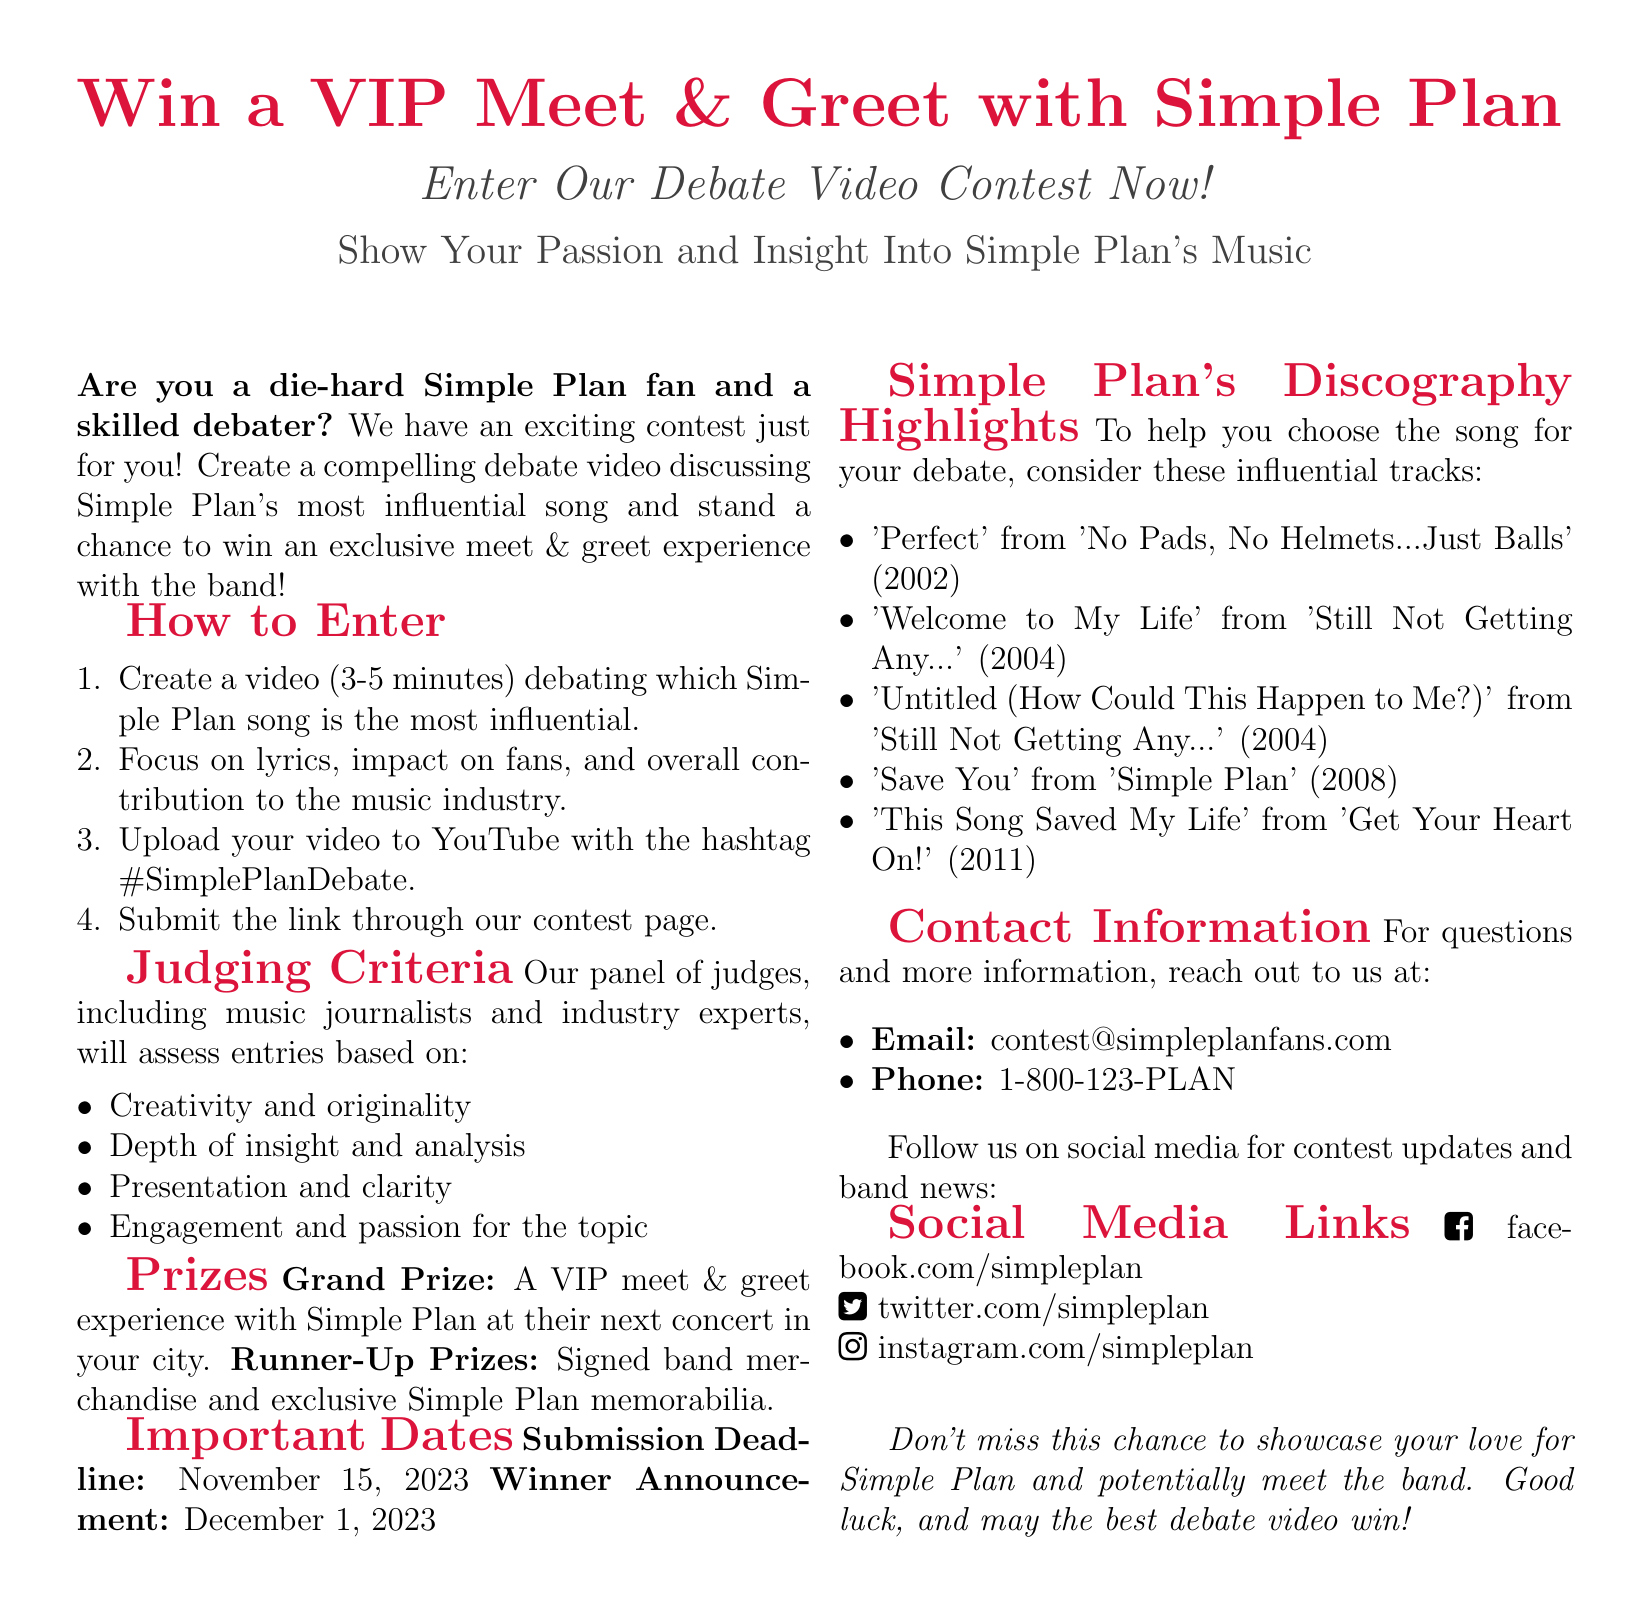What is the contest prize? The grand prize is a VIP meet & greet experience with Simple Plan at their next concert.
Answer: VIP meet & greet experience What is the video length requirement? The video should be between 3 to 5 minutes.
Answer: 3-5 minutes When is the submission deadline? The document states the submission deadline is November 15, 2023.
Answer: November 15, 2023 Which song is suggested to start the debate? The document highlights several songs, one being 'Perfect.'
Answer: 'Perfect' What will entries be judged on? The judging criteria include creativity, depth of insight, presentation, and engagement.
Answer: Creativity and originality How many runner-up prizes are mentioned? The document does not specify a number for runner-up prizes.
Answer: Not specified What is the announcement date for the winners? The winner announcement date is December 1, 2023.
Answer: December 1, 2023 Where should the videos be uploaded? Participants should upload their videos to YouTube.
Answer: YouTube 